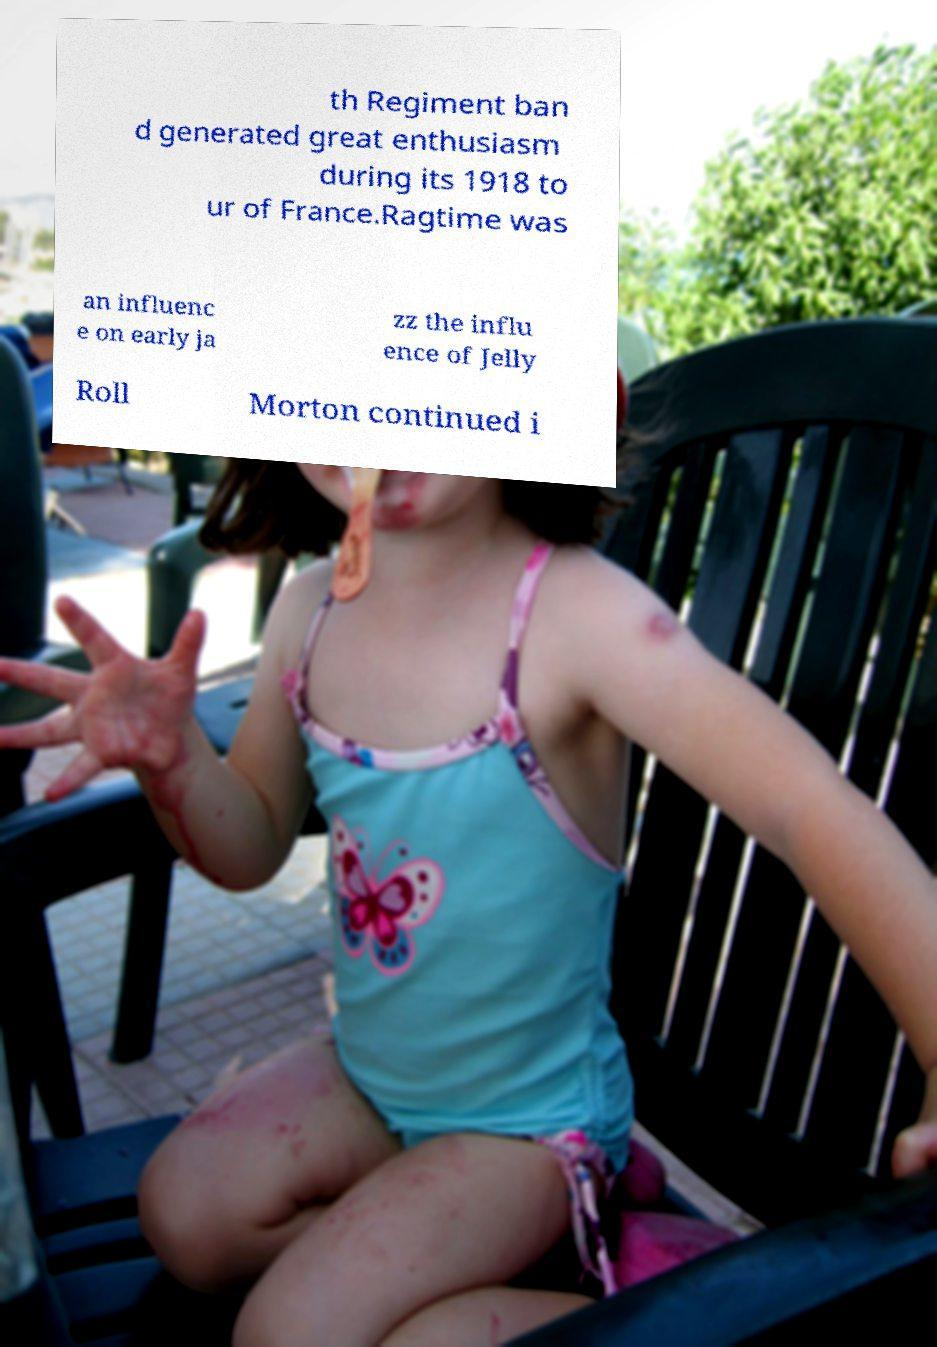Please read and relay the text visible in this image. What does it say? th Regiment ban d generated great enthusiasm during its 1918 to ur of France.Ragtime was an influenc e on early ja zz the influ ence of Jelly Roll Morton continued i 